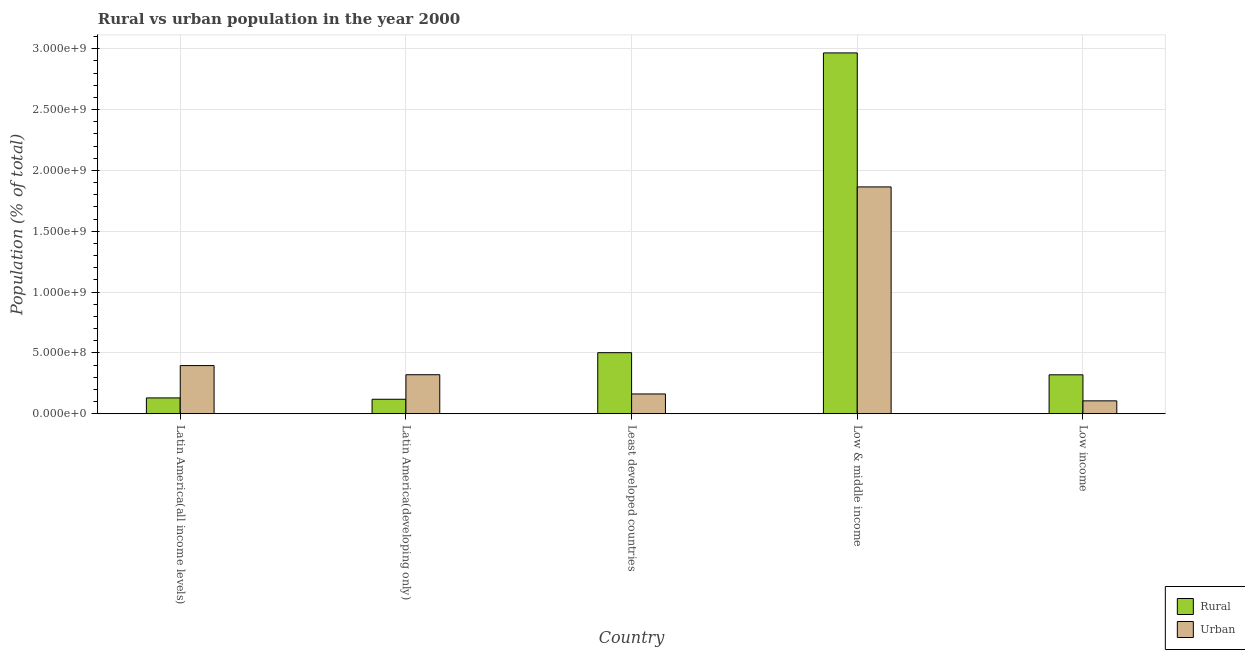How many different coloured bars are there?
Offer a very short reply. 2. How many groups of bars are there?
Your answer should be very brief. 5. Are the number of bars per tick equal to the number of legend labels?
Keep it short and to the point. Yes. What is the label of the 2nd group of bars from the left?
Your answer should be very brief. Latin America(developing only). In how many cases, is the number of bars for a given country not equal to the number of legend labels?
Provide a succinct answer. 0. What is the urban population density in Least developed countries?
Ensure brevity in your answer.  1.63e+08. Across all countries, what is the maximum rural population density?
Ensure brevity in your answer.  2.97e+09. Across all countries, what is the minimum urban population density?
Your answer should be very brief. 1.06e+08. In which country was the urban population density maximum?
Your response must be concise. Low & middle income. What is the total urban population density in the graph?
Provide a short and direct response. 2.85e+09. What is the difference between the urban population density in Least developed countries and that in Low income?
Ensure brevity in your answer.  5.66e+07. What is the difference between the urban population density in Latin America(developing only) and the rural population density in Least developed countries?
Provide a succinct answer. -1.81e+08. What is the average urban population density per country?
Offer a terse response. 5.70e+08. What is the difference between the rural population density and urban population density in Low income?
Your response must be concise. 2.14e+08. What is the ratio of the urban population density in Latin America(developing only) to that in Low income?
Offer a terse response. 3.03. Is the urban population density in Latin America(all income levels) less than that in Low income?
Your answer should be very brief. No. What is the difference between the highest and the second highest rural population density?
Your answer should be very brief. 2.46e+09. What is the difference between the highest and the lowest urban population density?
Your response must be concise. 1.76e+09. In how many countries, is the rural population density greater than the average rural population density taken over all countries?
Your answer should be very brief. 1. Is the sum of the urban population density in Least developed countries and Low & middle income greater than the maximum rural population density across all countries?
Ensure brevity in your answer.  No. What does the 1st bar from the left in Least developed countries represents?
Your answer should be very brief. Rural. What does the 1st bar from the right in Latin America(all income levels) represents?
Provide a short and direct response. Urban. What is the difference between two consecutive major ticks on the Y-axis?
Your response must be concise. 5.00e+08. Are the values on the major ticks of Y-axis written in scientific E-notation?
Your response must be concise. Yes. How are the legend labels stacked?
Offer a very short reply. Vertical. What is the title of the graph?
Your answer should be very brief. Rural vs urban population in the year 2000. What is the label or title of the X-axis?
Provide a succinct answer. Country. What is the label or title of the Y-axis?
Keep it short and to the point. Population (% of total). What is the Population (% of total) in Rural in Latin America(all income levels)?
Your response must be concise. 1.30e+08. What is the Population (% of total) of Urban in Latin America(all income levels)?
Make the answer very short. 3.96e+08. What is the Population (% of total) of Rural in Latin America(developing only)?
Your answer should be very brief. 1.19e+08. What is the Population (% of total) of Urban in Latin America(developing only)?
Offer a terse response. 3.21e+08. What is the Population (% of total) in Rural in Least developed countries?
Provide a succinct answer. 5.02e+08. What is the Population (% of total) in Urban in Least developed countries?
Offer a very short reply. 1.63e+08. What is the Population (% of total) in Rural in Low & middle income?
Keep it short and to the point. 2.97e+09. What is the Population (% of total) in Urban in Low & middle income?
Keep it short and to the point. 1.86e+09. What is the Population (% of total) in Rural in Low income?
Offer a terse response. 3.20e+08. What is the Population (% of total) of Urban in Low income?
Offer a terse response. 1.06e+08. Across all countries, what is the maximum Population (% of total) of Rural?
Give a very brief answer. 2.97e+09. Across all countries, what is the maximum Population (% of total) of Urban?
Keep it short and to the point. 1.86e+09. Across all countries, what is the minimum Population (% of total) in Rural?
Your answer should be very brief. 1.19e+08. Across all countries, what is the minimum Population (% of total) of Urban?
Provide a short and direct response. 1.06e+08. What is the total Population (% of total) in Rural in the graph?
Your response must be concise. 4.04e+09. What is the total Population (% of total) in Urban in the graph?
Offer a very short reply. 2.85e+09. What is the difference between the Population (% of total) of Rural in Latin America(all income levels) and that in Latin America(developing only)?
Make the answer very short. 1.11e+07. What is the difference between the Population (% of total) of Urban in Latin America(all income levels) and that in Latin America(developing only)?
Your response must be concise. 7.51e+07. What is the difference between the Population (% of total) of Rural in Latin America(all income levels) and that in Least developed countries?
Your answer should be very brief. -3.72e+08. What is the difference between the Population (% of total) of Urban in Latin America(all income levels) and that in Least developed countries?
Your answer should be compact. 2.33e+08. What is the difference between the Population (% of total) in Rural in Latin America(all income levels) and that in Low & middle income?
Provide a succinct answer. -2.84e+09. What is the difference between the Population (% of total) of Urban in Latin America(all income levels) and that in Low & middle income?
Provide a succinct answer. -1.47e+09. What is the difference between the Population (% of total) in Rural in Latin America(all income levels) and that in Low income?
Provide a succinct answer. -1.90e+08. What is the difference between the Population (% of total) of Urban in Latin America(all income levels) and that in Low income?
Provide a short and direct response. 2.90e+08. What is the difference between the Population (% of total) in Rural in Latin America(developing only) and that in Least developed countries?
Ensure brevity in your answer.  -3.83e+08. What is the difference between the Population (% of total) in Urban in Latin America(developing only) and that in Least developed countries?
Your answer should be very brief. 1.58e+08. What is the difference between the Population (% of total) in Rural in Latin America(developing only) and that in Low & middle income?
Offer a very short reply. -2.85e+09. What is the difference between the Population (% of total) in Urban in Latin America(developing only) and that in Low & middle income?
Offer a very short reply. -1.54e+09. What is the difference between the Population (% of total) in Rural in Latin America(developing only) and that in Low income?
Provide a short and direct response. -2.01e+08. What is the difference between the Population (% of total) in Urban in Latin America(developing only) and that in Low income?
Offer a terse response. 2.15e+08. What is the difference between the Population (% of total) of Rural in Least developed countries and that in Low & middle income?
Provide a succinct answer. -2.46e+09. What is the difference between the Population (% of total) of Urban in Least developed countries and that in Low & middle income?
Your response must be concise. -1.70e+09. What is the difference between the Population (% of total) of Rural in Least developed countries and that in Low income?
Provide a short and direct response. 1.82e+08. What is the difference between the Population (% of total) of Urban in Least developed countries and that in Low income?
Ensure brevity in your answer.  5.66e+07. What is the difference between the Population (% of total) of Rural in Low & middle income and that in Low income?
Make the answer very short. 2.65e+09. What is the difference between the Population (% of total) of Urban in Low & middle income and that in Low income?
Give a very brief answer. 1.76e+09. What is the difference between the Population (% of total) of Rural in Latin America(all income levels) and the Population (% of total) of Urban in Latin America(developing only)?
Offer a terse response. -1.91e+08. What is the difference between the Population (% of total) in Rural in Latin America(all income levels) and the Population (% of total) in Urban in Least developed countries?
Your answer should be very brief. -3.25e+07. What is the difference between the Population (% of total) of Rural in Latin America(all income levels) and the Population (% of total) of Urban in Low & middle income?
Ensure brevity in your answer.  -1.73e+09. What is the difference between the Population (% of total) in Rural in Latin America(all income levels) and the Population (% of total) in Urban in Low income?
Offer a very short reply. 2.41e+07. What is the difference between the Population (% of total) of Rural in Latin America(developing only) and the Population (% of total) of Urban in Least developed countries?
Provide a short and direct response. -4.35e+07. What is the difference between the Population (% of total) in Rural in Latin America(developing only) and the Population (% of total) in Urban in Low & middle income?
Give a very brief answer. -1.75e+09. What is the difference between the Population (% of total) in Rural in Latin America(developing only) and the Population (% of total) in Urban in Low income?
Offer a terse response. 1.30e+07. What is the difference between the Population (% of total) in Rural in Least developed countries and the Population (% of total) in Urban in Low & middle income?
Your answer should be very brief. -1.36e+09. What is the difference between the Population (% of total) in Rural in Least developed countries and the Population (% of total) in Urban in Low income?
Ensure brevity in your answer.  3.96e+08. What is the difference between the Population (% of total) of Rural in Low & middle income and the Population (% of total) of Urban in Low income?
Offer a terse response. 2.86e+09. What is the average Population (% of total) in Rural per country?
Your answer should be compact. 8.07e+08. What is the average Population (% of total) of Urban per country?
Make the answer very short. 5.70e+08. What is the difference between the Population (% of total) of Rural and Population (% of total) of Urban in Latin America(all income levels)?
Your answer should be very brief. -2.66e+08. What is the difference between the Population (% of total) in Rural and Population (% of total) in Urban in Latin America(developing only)?
Your answer should be compact. -2.02e+08. What is the difference between the Population (% of total) in Rural and Population (% of total) in Urban in Least developed countries?
Keep it short and to the point. 3.39e+08. What is the difference between the Population (% of total) of Rural and Population (% of total) of Urban in Low & middle income?
Keep it short and to the point. 1.10e+09. What is the difference between the Population (% of total) in Rural and Population (% of total) in Urban in Low income?
Offer a terse response. 2.14e+08. What is the ratio of the Population (% of total) of Rural in Latin America(all income levels) to that in Latin America(developing only)?
Keep it short and to the point. 1.09. What is the ratio of the Population (% of total) of Urban in Latin America(all income levels) to that in Latin America(developing only)?
Keep it short and to the point. 1.23. What is the ratio of the Population (% of total) of Rural in Latin America(all income levels) to that in Least developed countries?
Your answer should be very brief. 0.26. What is the ratio of the Population (% of total) of Urban in Latin America(all income levels) to that in Least developed countries?
Your answer should be compact. 2.44. What is the ratio of the Population (% of total) in Rural in Latin America(all income levels) to that in Low & middle income?
Give a very brief answer. 0.04. What is the ratio of the Population (% of total) in Urban in Latin America(all income levels) to that in Low & middle income?
Offer a very short reply. 0.21. What is the ratio of the Population (% of total) in Rural in Latin America(all income levels) to that in Low income?
Ensure brevity in your answer.  0.41. What is the ratio of the Population (% of total) of Urban in Latin America(all income levels) to that in Low income?
Your answer should be very brief. 3.74. What is the ratio of the Population (% of total) of Rural in Latin America(developing only) to that in Least developed countries?
Offer a terse response. 0.24. What is the ratio of the Population (% of total) in Urban in Latin America(developing only) to that in Least developed countries?
Provide a succinct answer. 1.97. What is the ratio of the Population (% of total) in Rural in Latin America(developing only) to that in Low & middle income?
Give a very brief answer. 0.04. What is the ratio of the Population (% of total) of Urban in Latin America(developing only) to that in Low & middle income?
Ensure brevity in your answer.  0.17. What is the ratio of the Population (% of total) in Rural in Latin America(developing only) to that in Low income?
Offer a terse response. 0.37. What is the ratio of the Population (% of total) in Urban in Latin America(developing only) to that in Low income?
Provide a succinct answer. 3.03. What is the ratio of the Population (% of total) of Rural in Least developed countries to that in Low & middle income?
Keep it short and to the point. 0.17. What is the ratio of the Population (% of total) of Urban in Least developed countries to that in Low & middle income?
Ensure brevity in your answer.  0.09. What is the ratio of the Population (% of total) of Rural in Least developed countries to that in Low income?
Your answer should be very brief. 1.57. What is the ratio of the Population (% of total) of Urban in Least developed countries to that in Low income?
Offer a very short reply. 1.53. What is the ratio of the Population (% of total) in Rural in Low & middle income to that in Low income?
Provide a short and direct response. 9.27. What is the ratio of the Population (% of total) of Urban in Low & middle income to that in Low income?
Keep it short and to the point. 17.6. What is the difference between the highest and the second highest Population (% of total) of Rural?
Give a very brief answer. 2.46e+09. What is the difference between the highest and the second highest Population (% of total) of Urban?
Offer a terse response. 1.47e+09. What is the difference between the highest and the lowest Population (% of total) of Rural?
Your answer should be compact. 2.85e+09. What is the difference between the highest and the lowest Population (% of total) of Urban?
Your answer should be very brief. 1.76e+09. 